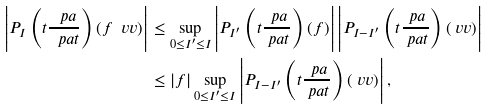<formula> <loc_0><loc_0><loc_500><loc_500>\left | P _ { I } \left ( t \frac { \ p a } { \ p a t } \right ) ( f \ v v ) \right | & \leq \sup _ { 0 \leq I ^ { \prime } \leq I } \left | P _ { I ^ { \prime } } \left ( t \frac { \ p a } { \ p a t } \right ) ( f ) \right | \left | P _ { I - I ^ { \prime } } \left ( t \frac { \ p a } { \ p a t } \right ) ( \ v v ) \right | \\ & \leq | f | \sup _ { 0 \leq I ^ { \prime } \leq I } \left | P _ { I - I ^ { \prime } } \left ( t \frac { \ p a } { \ p a t } \right ) ( \ v v ) \right | ,</formula> 